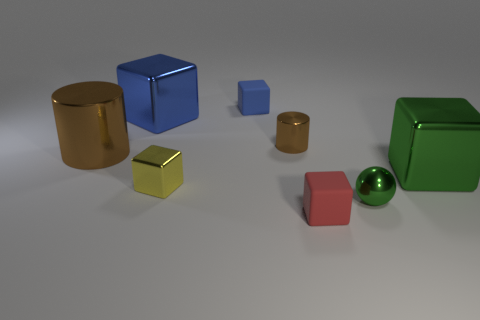Subtract all yellow balls. How many blue blocks are left? 2 Subtract all blue metallic blocks. How many blocks are left? 4 Add 1 rubber cylinders. How many objects exist? 9 Subtract all yellow cubes. How many cubes are left? 4 Subtract 2 cubes. How many cubes are left? 3 Subtract all cubes. How many objects are left? 3 Subtract all yellow cubes. Subtract all green cylinders. How many cubes are left? 4 Subtract all big things. Subtract all large blue objects. How many objects are left? 4 Add 5 small yellow things. How many small yellow things are left? 6 Add 3 shiny things. How many shiny things exist? 9 